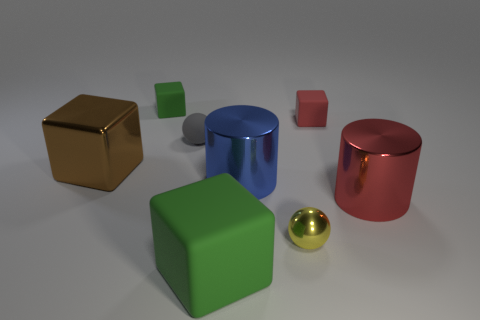There is a red thing that is the same material as the yellow object; what is its shape?
Your response must be concise. Cylinder. Are there any other things of the same color as the big matte block?
Your answer should be compact. Yes. What is the material of the tiny gray object that is the same shape as the tiny yellow object?
Ensure brevity in your answer.  Rubber. How many other things are the same size as the blue cylinder?
Make the answer very short. 3. There is a rubber cube that is the same color as the large rubber object; what is its size?
Offer a very short reply. Small. Does the green object in front of the red metallic cylinder have the same shape as the small metal object?
Provide a succinct answer. No. How many other things are there of the same shape as the tiny gray matte thing?
Make the answer very short. 1. What shape is the yellow thing that is in front of the gray matte thing?
Your answer should be compact. Sphere. Are there any brown balls that have the same material as the big blue cylinder?
Offer a very short reply. No. Do the large cube behind the large red object and the tiny metal sphere have the same color?
Offer a terse response. No. 